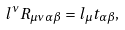<formula> <loc_0><loc_0><loc_500><loc_500>l ^ { \nu } R _ { \mu \nu \, \alpha \beta } = l _ { \mu } t _ { \alpha \beta } ,</formula> 